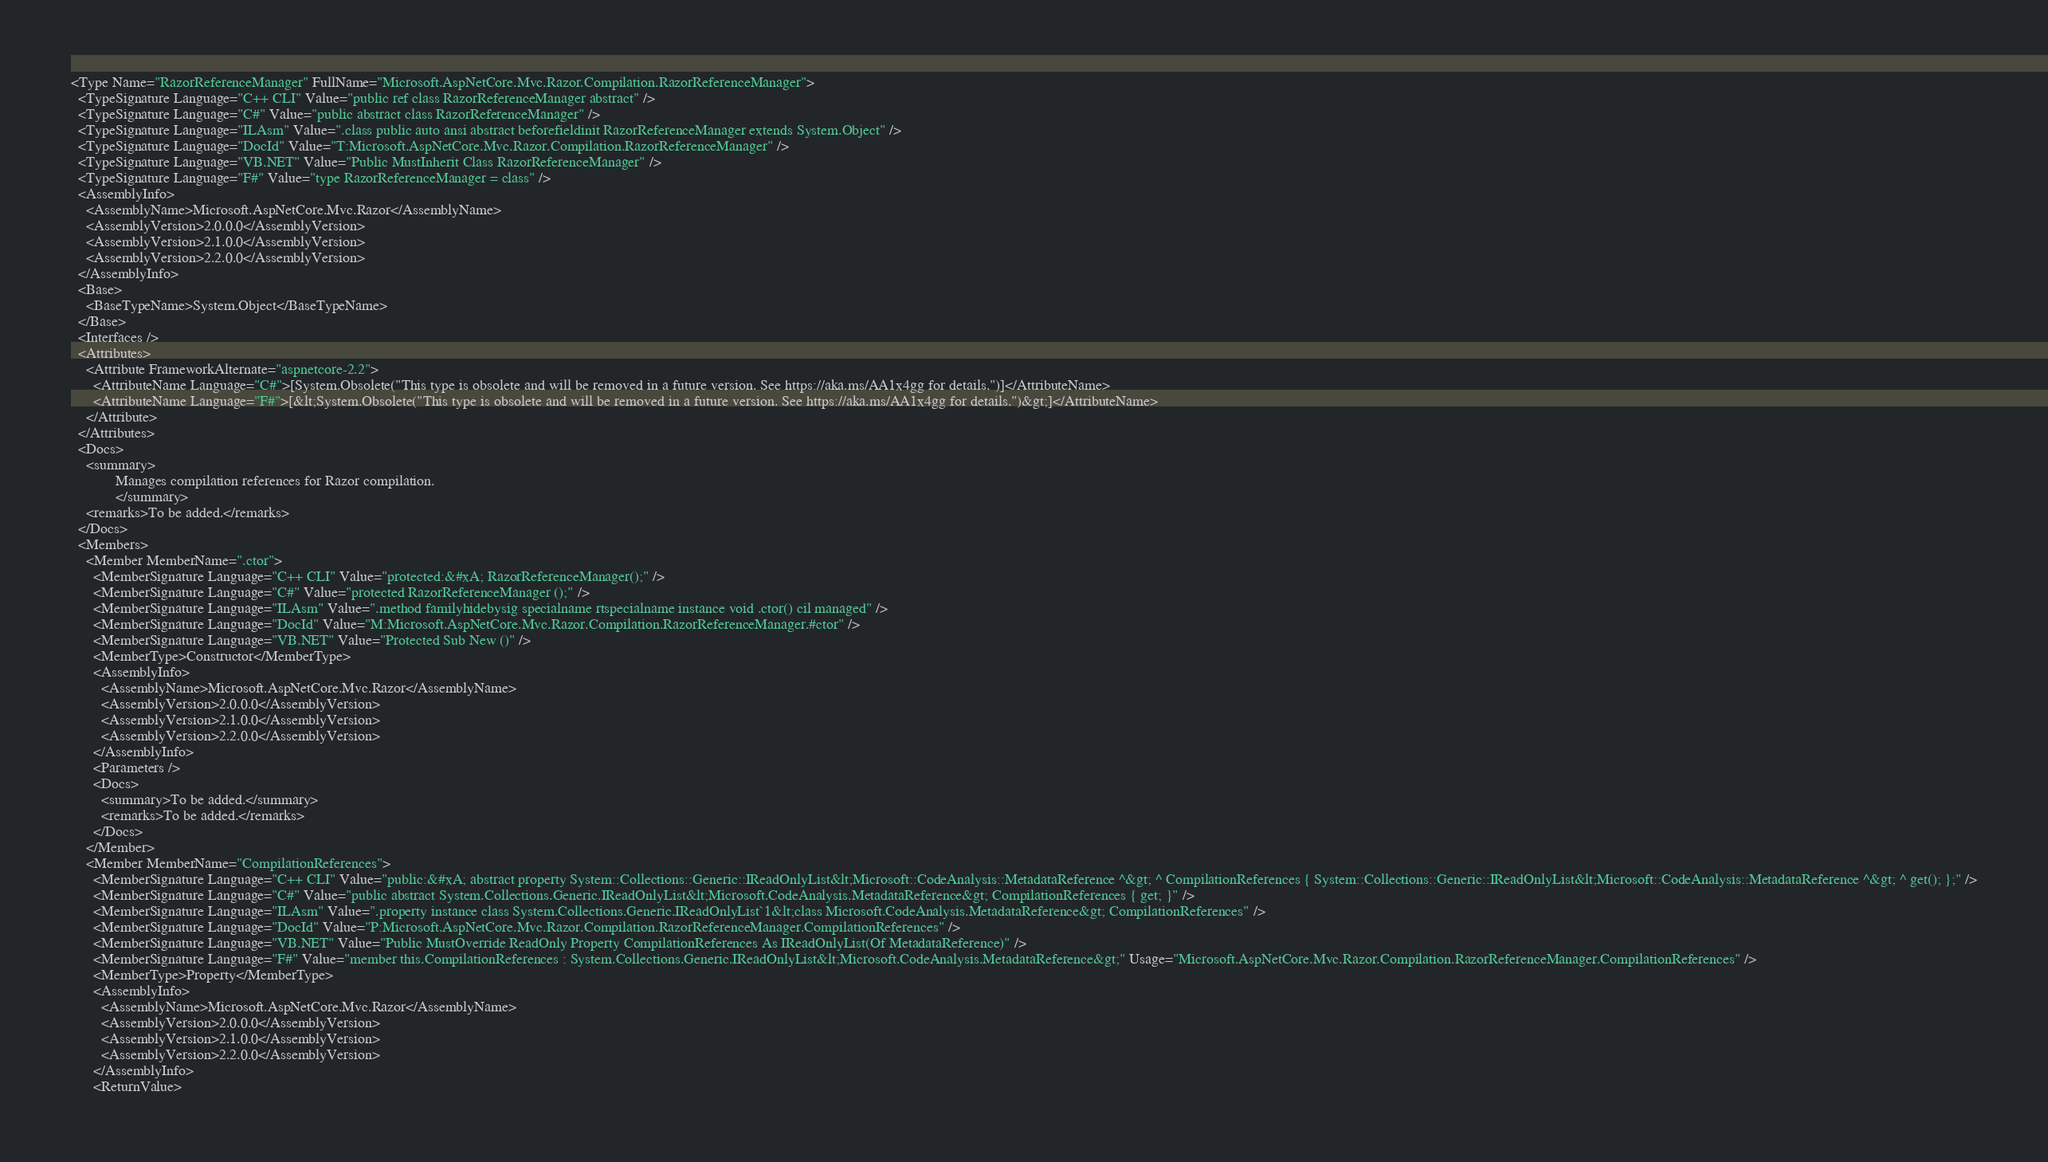<code> <loc_0><loc_0><loc_500><loc_500><_XML_><Type Name="RazorReferenceManager" FullName="Microsoft.AspNetCore.Mvc.Razor.Compilation.RazorReferenceManager">
  <TypeSignature Language="C++ CLI" Value="public ref class RazorReferenceManager abstract" />
  <TypeSignature Language="C#" Value="public abstract class RazorReferenceManager" />
  <TypeSignature Language="ILAsm" Value=".class public auto ansi abstract beforefieldinit RazorReferenceManager extends System.Object" />
  <TypeSignature Language="DocId" Value="T:Microsoft.AspNetCore.Mvc.Razor.Compilation.RazorReferenceManager" />
  <TypeSignature Language="VB.NET" Value="Public MustInherit Class RazorReferenceManager" />
  <TypeSignature Language="F#" Value="type RazorReferenceManager = class" />
  <AssemblyInfo>
    <AssemblyName>Microsoft.AspNetCore.Mvc.Razor</AssemblyName>
    <AssemblyVersion>2.0.0.0</AssemblyVersion>
    <AssemblyVersion>2.1.0.0</AssemblyVersion>
    <AssemblyVersion>2.2.0.0</AssemblyVersion>
  </AssemblyInfo>
  <Base>
    <BaseTypeName>System.Object</BaseTypeName>
  </Base>
  <Interfaces />
  <Attributes>
    <Attribute FrameworkAlternate="aspnetcore-2.2">
      <AttributeName Language="C#">[System.Obsolete("This type is obsolete and will be removed in a future version. See https://aka.ms/AA1x4gg for details.")]</AttributeName>
      <AttributeName Language="F#">[&lt;System.Obsolete("This type is obsolete and will be removed in a future version. See https://aka.ms/AA1x4gg for details.")&gt;]</AttributeName>
    </Attribute>
  </Attributes>
  <Docs>
    <summary>
            Manages compilation references for Razor compilation.
            </summary>
    <remarks>To be added.</remarks>
  </Docs>
  <Members>
    <Member MemberName=".ctor">
      <MemberSignature Language="C++ CLI" Value="protected:&#xA; RazorReferenceManager();" />
      <MemberSignature Language="C#" Value="protected RazorReferenceManager ();" />
      <MemberSignature Language="ILAsm" Value=".method familyhidebysig specialname rtspecialname instance void .ctor() cil managed" />
      <MemberSignature Language="DocId" Value="M:Microsoft.AspNetCore.Mvc.Razor.Compilation.RazorReferenceManager.#ctor" />
      <MemberSignature Language="VB.NET" Value="Protected Sub New ()" />
      <MemberType>Constructor</MemberType>
      <AssemblyInfo>
        <AssemblyName>Microsoft.AspNetCore.Mvc.Razor</AssemblyName>
        <AssemblyVersion>2.0.0.0</AssemblyVersion>
        <AssemblyVersion>2.1.0.0</AssemblyVersion>
        <AssemblyVersion>2.2.0.0</AssemblyVersion>
      </AssemblyInfo>
      <Parameters />
      <Docs>
        <summary>To be added.</summary>
        <remarks>To be added.</remarks>
      </Docs>
    </Member>
    <Member MemberName="CompilationReferences">
      <MemberSignature Language="C++ CLI" Value="public:&#xA; abstract property System::Collections::Generic::IReadOnlyList&lt;Microsoft::CodeAnalysis::MetadataReference ^&gt; ^ CompilationReferences { System::Collections::Generic::IReadOnlyList&lt;Microsoft::CodeAnalysis::MetadataReference ^&gt; ^ get(); };" />
      <MemberSignature Language="C#" Value="public abstract System.Collections.Generic.IReadOnlyList&lt;Microsoft.CodeAnalysis.MetadataReference&gt; CompilationReferences { get; }" />
      <MemberSignature Language="ILAsm" Value=".property instance class System.Collections.Generic.IReadOnlyList`1&lt;class Microsoft.CodeAnalysis.MetadataReference&gt; CompilationReferences" />
      <MemberSignature Language="DocId" Value="P:Microsoft.AspNetCore.Mvc.Razor.Compilation.RazorReferenceManager.CompilationReferences" />
      <MemberSignature Language="VB.NET" Value="Public MustOverride ReadOnly Property CompilationReferences As IReadOnlyList(Of MetadataReference)" />
      <MemberSignature Language="F#" Value="member this.CompilationReferences : System.Collections.Generic.IReadOnlyList&lt;Microsoft.CodeAnalysis.MetadataReference&gt;" Usage="Microsoft.AspNetCore.Mvc.Razor.Compilation.RazorReferenceManager.CompilationReferences" />
      <MemberType>Property</MemberType>
      <AssemblyInfo>
        <AssemblyName>Microsoft.AspNetCore.Mvc.Razor</AssemblyName>
        <AssemblyVersion>2.0.0.0</AssemblyVersion>
        <AssemblyVersion>2.1.0.0</AssemblyVersion>
        <AssemblyVersion>2.2.0.0</AssemblyVersion>
      </AssemblyInfo>
      <ReturnValue></code> 